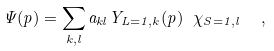<formula> <loc_0><loc_0><loc_500><loc_500>\Psi ( p ) = \sum _ { k , l } a _ { k l } Y _ { L = 1 , k } ( p ) \ \chi _ { S = 1 , l } \ \ ,</formula> 